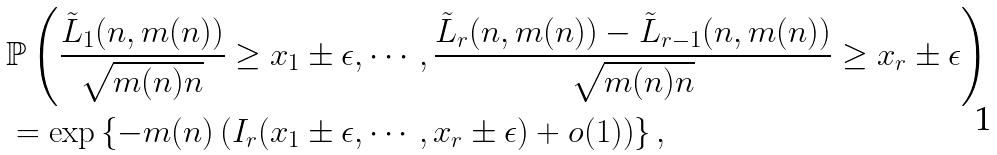<formula> <loc_0><loc_0><loc_500><loc_500>& \mathbb { P } \left ( \frac { \tilde { L } _ { 1 } ( n , m ( n ) ) } { \sqrt { m ( n ) n } } \geq x _ { 1 } \pm \epsilon , \cdots , \frac { \tilde { L } _ { r } ( n , m ( n ) ) - \tilde { L } _ { r - 1 } ( n , m ( n ) ) } { \sqrt { m ( n ) n } } \geq x _ { r } \pm \epsilon \right ) \\ & = \exp \left \{ - m ( n ) \left ( I _ { r } ( x _ { 1 } \pm \epsilon , \cdots , x _ { r } \pm \epsilon ) + o ( 1 ) \right ) \right \} ,</formula> 